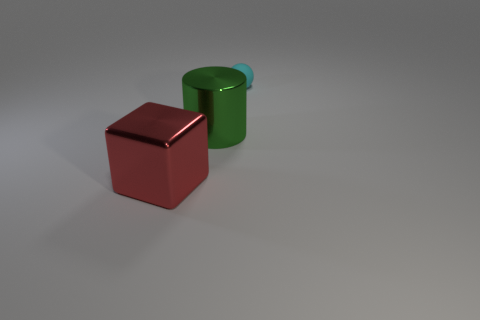How many blue metallic cubes are there?
Provide a short and direct response. 0. How many cylinders are either red objects or tiny cyan objects?
Your response must be concise. 0. How many cubes are right of the large object that is in front of the big metal object to the right of the red metallic block?
Ensure brevity in your answer.  0. What color is the object that is the same size as the shiny cylinder?
Your answer should be very brief. Red. How many other things are there of the same color as the large cylinder?
Offer a very short reply. 0. Are there more cylinders in front of the big red block than red shiny things?
Your answer should be compact. No. Does the big red thing have the same material as the tiny cyan ball?
Your answer should be compact. No. What number of things are large things on the left side of the large green metal cylinder or big red metallic blocks?
Provide a short and direct response. 1. What number of other things are there of the same size as the red object?
Make the answer very short. 1. Is the number of green objects that are right of the sphere the same as the number of large blocks right of the red shiny block?
Offer a very short reply. Yes. 